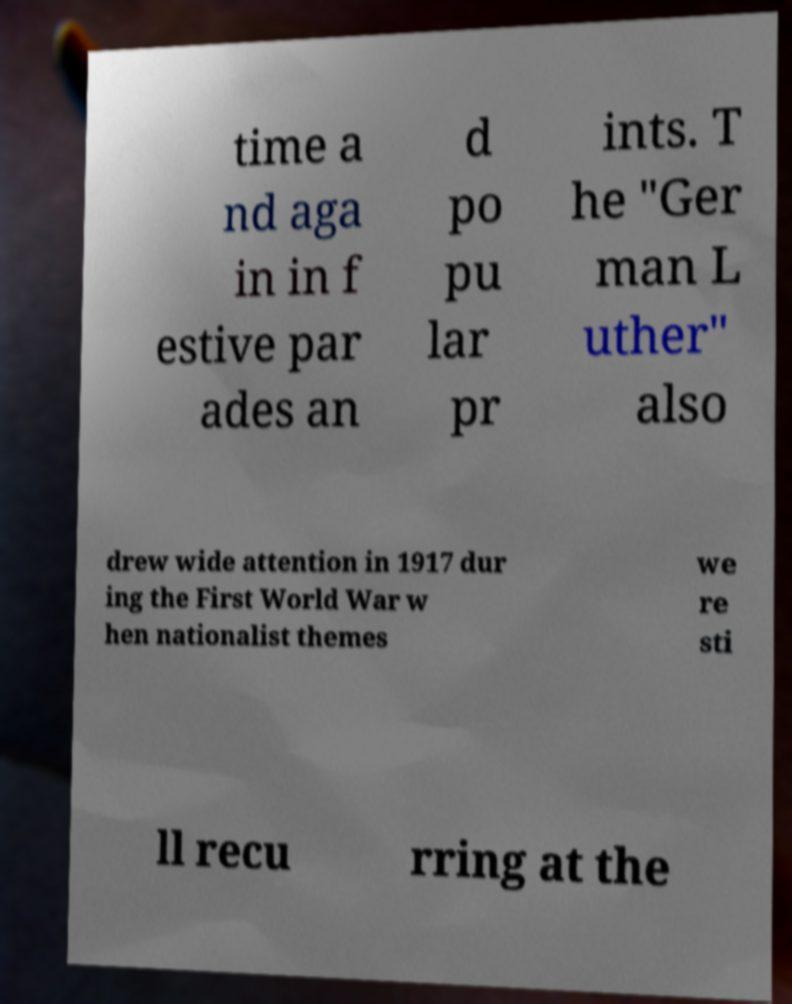Please read and relay the text visible in this image. What does it say? time a nd aga in in f estive par ades an d po pu lar pr ints. T he "Ger man L uther" also drew wide attention in 1917 dur ing the First World War w hen nationalist themes we re sti ll recu rring at the 